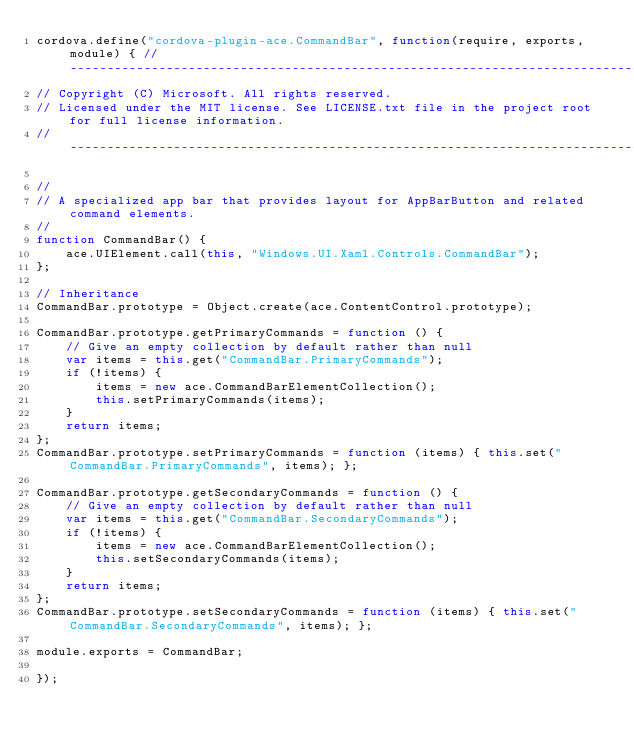<code> <loc_0><loc_0><loc_500><loc_500><_JavaScript_>cordova.define("cordova-plugin-ace.CommandBar", function(require, exports, module) { //-------------------------------------------------------------------------------------------------------
// Copyright (C) Microsoft. All rights reserved.
// Licensed under the MIT license. See LICENSE.txt file in the project root for full license information.
//-------------------------------------------------------------------------------------------------------

//
// A specialized app bar that provides layout for AppBarButton and related command elements.
//
function CommandBar() {
    ace.UIElement.call(this, "Windows.UI.Xaml.Controls.CommandBar");
};

// Inheritance
CommandBar.prototype = Object.create(ace.ContentControl.prototype);

CommandBar.prototype.getPrimaryCommands = function () {
    // Give an empty collection by default rather than null
    var items = this.get("CommandBar.PrimaryCommands");
    if (!items) {
        items = new ace.CommandBarElementCollection();
        this.setPrimaryCommands(items);
    }
    return items;
};
CommandBar.prototype.setPrimaryCommands = function (items) { this.set("CommandBar.PrimaryCommands", items); };

CommandBar.prototype.getSecondaryCommands = function () {
    // Give an empty collection by default rather than null
    var items = this.get("CommandBar.SecondaryCommands");
    if (!items) {
        items = new ace.CommandBarElementCollection();
        this.setSecondaryCommands(items);
    }
    return items;
};
CommandBar.prototype.setSecondaryCommands = function (items) { this.set("CommandBar.SecondaryCommands", items); };

module.exports = CommandBar;

});
</code> 